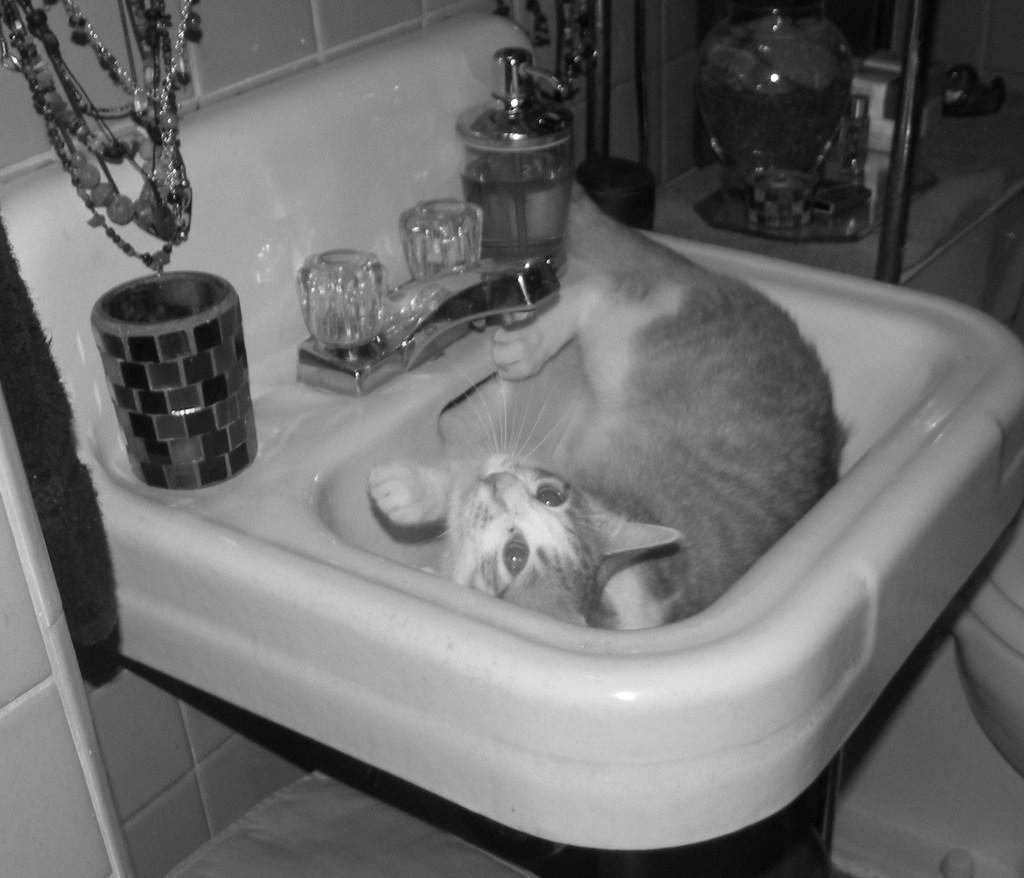Could you give a brief overview of what you see in this image? This image is a black and white image. This image is taken indoors. In the middle of the image there is a sink with a tap and a few things on it and there is a cat in the sink. In the background there is a wall and there are a few chains. There is a shelf with a few things on it. At the bottom of the image there is a floor. 